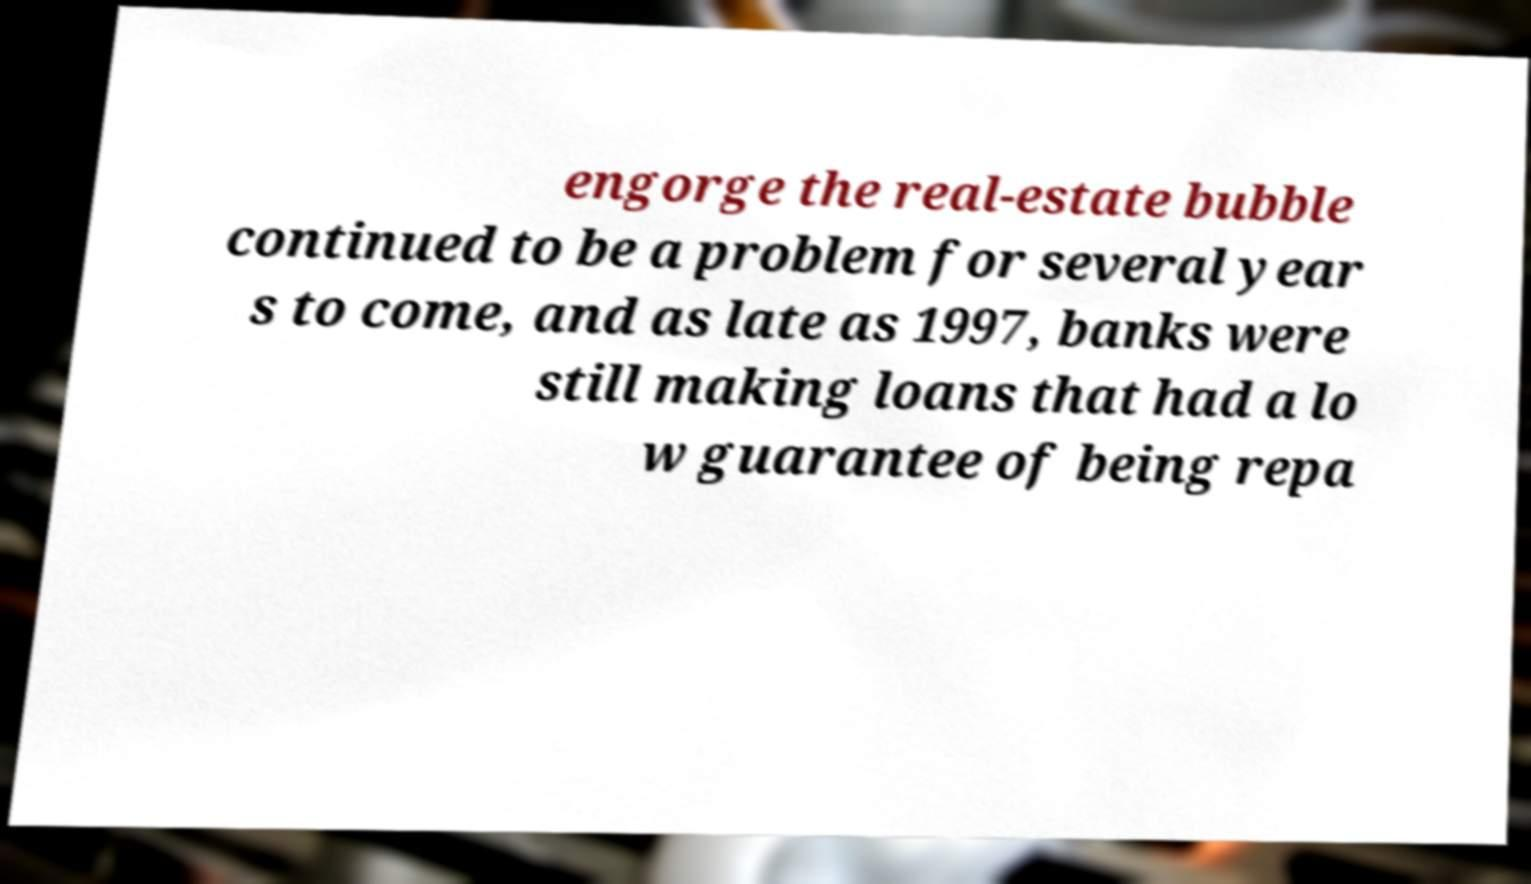Please read and relay the text visible in this image. What does it say? engorge the real-estate bubble continued to be a problem for several year s to come, and as late as 1997, banks were still making loans that had a lo w guarantee of being repa 